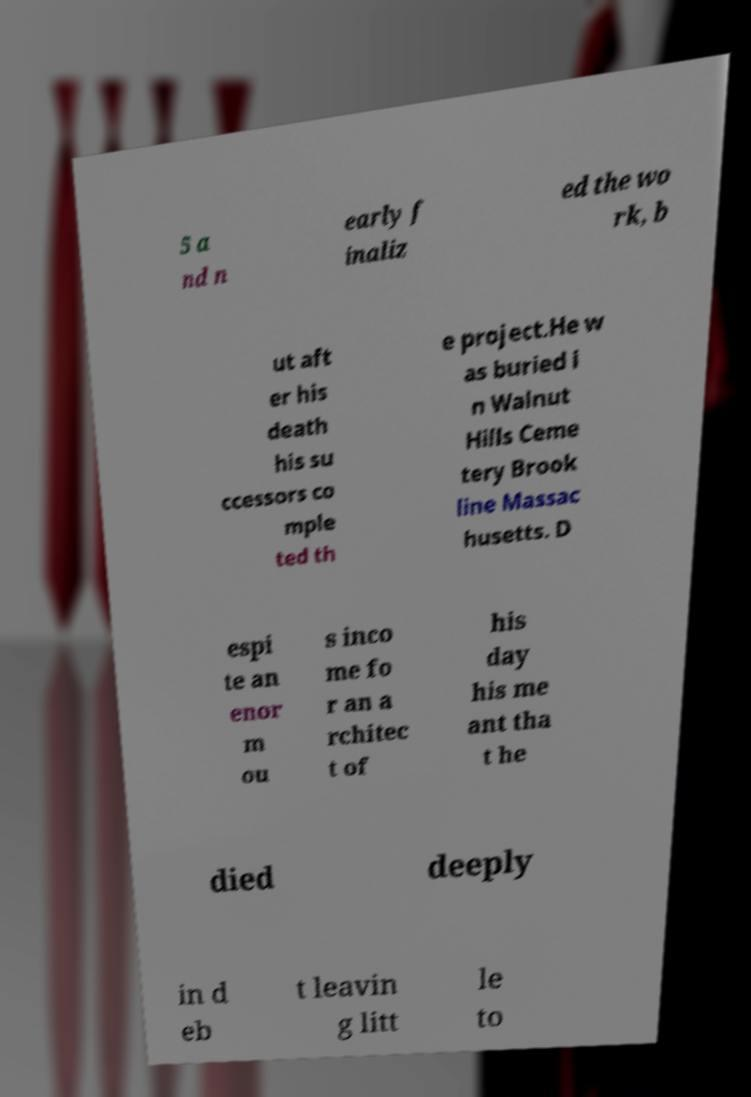Can you read and provide the text displayed in the image?This photo seems to have some interesting text. Can you extract and type it out for me? 5 a nd n early f inaliz ed the wo rk, b ut aft er his death his su ccessors co mple ted th e project.He w as buried i n Walnut Hills Ceme tery Brook line Massac husetts. D espi te an enor m ou s inco me fo r an a rchitec t of his day his me ant tha t he died deeply in d eb t leavin g litt le to 